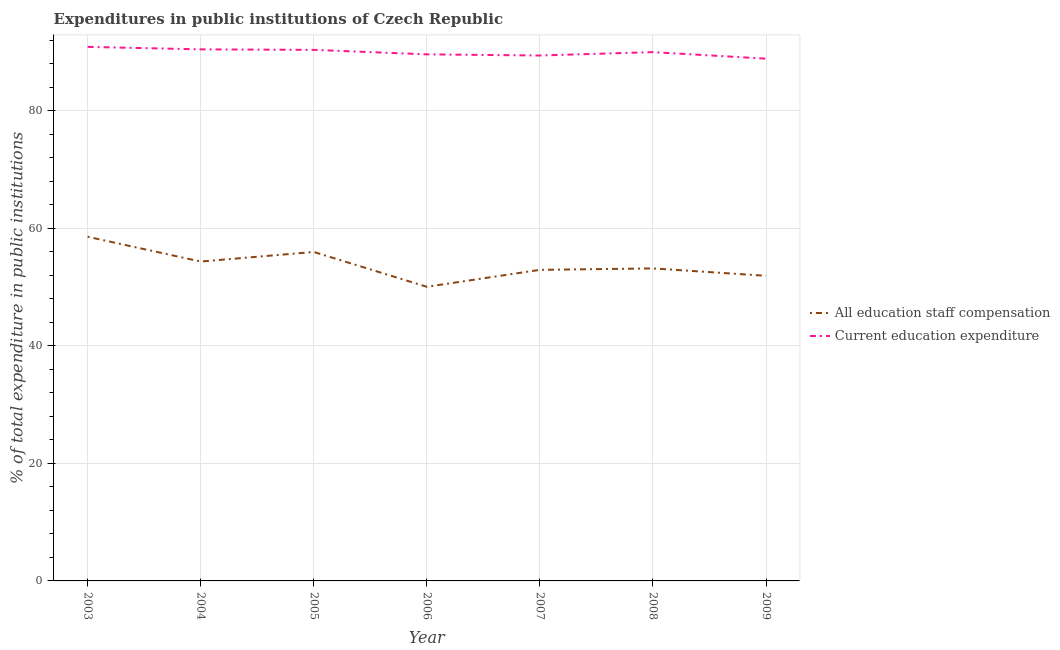How many different coloured lines are there?
Provide a short and direct response. 2. What is the expenditure in education in 2007?
Offer a very short reply. 89.38. Across all years, what is the maximum expenditure in staff compensation?
Give a very brief answer. 58.55. Across all years, what is the minimum expenditure in education?
Provide a short and direct response. 88.84. In which year was the expenditure in staff compensation maximum?
Keep it short and to the point. 2003. What is the total expenditure in staff compensation in the graph?
Make the answer very short. 376.86. What is the difference between the expenditure in education in 2006 and that in 2007?
Your response must be concise. 0.19. What is the difference between the expenditure in staff compensation in 2007 and the expenditure in education in 2008?
Offer a terse response. -37.04. What is the average expenditure in education per year?
Your response must be concise. 89.91. In the year 2003, what is the difference between the expenditure in education and expenditure in staff compensation?
Provide a short and direct response. 32.3. In how many years, is the expenditure in education greater than 60 %?
Provide a short and direct response. 7. What is the ratio of the expenditure in staff compensation in 2005 to that in 2008?
Your answer should be compact. 1.05. Is the difference between the expenditure in education in 2004 and 2009 greater than the difference between the expenditure in staff compensation in 2004 and 2009?
Ensure brevity in your answer.  No. What is the difference between the highest and the second highest expenditure in staff compensation?
Your response must be concise. 2.59. What is the difference between the highest and the lowest expenditure in staff compensation?
Keep it short and to the point. 8.51. How many years are there in the graph?
Keep it short and to the point. 7. What is the difference between two consecutive major ticks on the Y-axis?
Offer a very short reply. 20. Are the values on the major ticks of Y-axis written in scientific E-notation?
Provide a short and direct response. No. How many legend labels are there?
Provide a succinct answer. 2. How are the legend labels stacked?
Ensure brevity in your answer.  Vertical. What is the title of the graph?
Your answer should be very brief. Expenditures in public institutions of Czech Republic. What is the label or title of the X-axis?
Your response must be concise. Year. What is the label or title of the Y-axis?
Make the answer very short. % of total expenditure in public institutions. What is the % of total expenditure in public institutions of All education staff compensation in 2003?
Offer a very short reply. 58.55. What is the % of total expenditure in public institutions in Current education expenditure in 2003?
Provide a succinct answer. 90.85. What is the % of total expenditure in public institutions in All education staff compensation in 2004?
Give a very brief answer. 54.33. What is the % of total expenditure in public institutions in Current education expenditure in 2004?
Ensure brevity in your answer.  90.43. What is the % of total expenditure in public institutions of All education staff compensation in 2005?
Provide a short and direct response. 55.96. What is the % of total expenditure in public institutions in Current education expenditure in 2005?
Your response must be concise. 90.34. What is the % of total expenditure in public institutions of All education staff compensation in 2006?
Provide a succinct answer. 50.03. What is the % of total expenditure in public institutions in Current education expenditure in 2006?
Make the answer very short. 89.57. What is the % of total expenditure in public institutions in All education staff compensation in 2007?
Your response must be concise. 52.92. What is the % of total expenditure in public institutions in Current education expenditure in 2007?
Keep it short and to the point. 89.38. What is the % of total expenditure in public institutions of All education staff compensation in 2008?
Your answer should be compact. 53.16. What is the % of total expenditure in public institutions of Current education expenditure in 2008?
Offer a terse response. 89.96. What is the % of total expenditure in public institutions in All education staff compensation in 2009?
Your answer should be compact. 51.91. What is the % of total expenditure in public institutions in Current education expenditure in 2009?
Your answer should be very brief. 88.84. Across all years, what is the maximum % of total expenditure in public institutions in All education staff compensation?
Offer a terse response. 58.55. Across all years, what is the maximum % of total expenditure in public institutions of Current education expenditure?
Your response must be concise. 90.85. Across all years, what is the minimum % of total expenditure in public institutions in All education staff compensation?
Give a very brief answer. 50.03. Across all years, what is the minimum % of total expenditure in public institutions in Current education expenditure?
Provide a short and direct response. 88.84. What is the total % of total expenditure in public institutions of All education staff compensation in the graph?
Make the answer very short. 376.86. What is the total % of total expenditure in public institutions of Current education expenditure in the graph?
Offer a terse response. 629.37. What is the difference between the % of total expenditure in public institutions of All education staff compensation in 2003 and that in 2004?
Your answer should be compact. 4.22. What is the difference between the % of total expenditure in public institutions in Current education expenditure in 2003 and that in 2004?
Make the answer very short. 0.42. What is the difference between the % of total expenditure in public institutions in All education staff compensation in 2003 and that in 2005?
Offer a very short reply. 2.59. What is the difference between the % of total expenditure in public institutions of Current education expenditure in 2003 and that in 2005?
Keep it short and to the point. 0.51. What is the difference between the % of total expenditure in public institutions of All education staff compensation in 2003 and that in 2006?
Offer a terse response. 8.51. What is the difference between the % of total expenditure in public institutions in Current education expenditure in 2003 and that in 2006?
Ensure brevity in your answer.  1.27. What is the difference between the % of total expenditure in public institutions of All education staff compensation in 2003 and that in 2007?
Your answer should be very brief. 5.63. What is the difference between the % of total expenditure in public institutions of Current education expenditure in 2003 and that in 2007?
Your answer should be very brief. 1.47. What is the difference between the % of total expenditure in public institutions of All education staff compensation in 2003 and that in 2008?
Ensure brevity in your answer.  5.39. What is the difference between the % of total expenditure in public institutions of Current education expenditure in 2003 and that in 2008?
Your answer should be compact. 0.89. What is the difference between the % of total expenditure in public institutions in All education staff compensation in 2003 and that in 2009?
Your response must be concise. 6.64. What is the difference between the % of total expenditure in public institutions in Current education expenditure in 2003 and that in 2009?
Offer a terse response. 2.01. What is the difference between the % of total expenditure in public institutions of All education staff compensation in 2004 and that in 2005?
Your response must be concise. -1.63. What is the difference between the % of total expenditure in public institutions in Current education expenditure in 2004 and that in 2005?
Make the answer very short. 0.09. What is the difference between the % of total expenditure in public institutions in All education staff compensation in 2004 and that in 2006?
Your answer should be compact. 4.3. What is the difference between the % of total expenditure in public institutions in Current education expenditure in 2004 and that in 2006?
Give a very brief answer. 0.85. What is the difference between the % of total expenditure in public institutions in All education staff compensation in 2004 and that in 2007?
Your answer should be very brief. 1.41. What is the difference between the % of total expenditure in public institutions of Current education expenditure in 2004 and that in 2007?
Ensure brevity in your answer.  1.04. What is the difference between the % of total expenditure in public institutions of All education staff compensation in 2004 and that in 2008?
Make the answer very short. 1.17. What is the difference between the % of total expenditure in public institutions of Current education expenditure in 2004 and that in 2008?
Provide a short and direct response. 0.47. What is the difference between the % of total expenditure in public institutions of All education staff compensation in 2004 and that in 2009?
Your response must be concise. 2.42. What is the difference between the % of total expenditure in public institutions in Current education expenditure in 2004 and that in 2009?
Ensure brevity in your answer.  1.58. What is the difference between the % of total expenditure in public institutions of All education staff compensation in 2005 and that in 2006?
Give a very brief answer. 5.93. What is the difference between the % of total expenditure in public institutions of Current education expenditure in 2005 and that in 2006?
Give a very brief answer. 0.77. What is the difference between the % of total expenditure in public institutions of All education staff compensation in 2005 and that in 2007?
Make the answer very short. 3.04. What is the difference between the % of total expenditure in public institutions in Current education expenditure in 2005 and that in 2007?
Ensure brevity in your answer.  0.96. What is the difference between the % of total expenditure in public institutions of All education staff compensation in 2005 and that in 2008?
Ensure brevity in your answer.  2.8. What is the difference between the % of total expenditure in public institutions of Current education expenditure in 2005 and that in 2008?
Ensure brevity in your answer.  0.38. What is the difference between the % of total expenditure in public institutions in All education staff compensation in 2005 and that in 2009?
Your answer should be very brief. 4.06. What is the difference between the % of total expenditure in public institutions of Current education expenditure in 2005 and that in 2009?
Provide a short and direct response. 1.5. What is the difference between the % of total expenditure in public institutions in All education staff compensation in 2006 and that in 2007?
Your response must be concise. -2.88. What is the difference between the % of total expenditure in public institutions in Current education expenditure in 2006 and that in 2007?
Make the answer very short. 0.19. What is the difference between the % of total expenditure in public institutions of All education staff compensation in 2006 and that in 2008?
Your response must be concise. -3.13. What is the difference between the % of total expenditure in public institutions in Current education expenditure in 2006 and that in 2008?
Ensure brevity in your answer.  -0.38. What is the difference between the % of total expenditure in public institutions in All education staff compensation in 2006 and that in 2009?
Your answer should be compact. -1.87. What is the difference between the % of total expenditure in public institutions in Current education expenditure in 2006 and that in 2009?
Keep it short and to the point. 0.73. What is the difference between the % of total expenditure in public institutions in All education staff compensation in 2007 and that in 2008?
Your answer should be very brief. -0.24. What is the difference between the % of total expenditure in public institutions of Current education expenditure in 2007 and that in 2008?
Give a very brief answer. -0.57. What is the difference between the % of total expenditure in public institutions in All education staff compensation in 2007 and that in 2009?
Provide a succinct answer. 1.01. What is the difference between the % of total expenditure in public institutions of Current education expenditure in 2007 and that in 2009?
Provide a succinct answer. 0.54. What is the difference between the % of total expenditure in public institutions in All education staff compensation in 2008 and that in 2009?
Keep it short and to the point. 1.25. What is the difference between the % of total expenditure in public institutions of Current education expenditure in 2008 and that in 2009?
Your answer should be compact. 1.11. What is the difference between the % of total expenditure in public institutions of All education staff compensation in 2003 and the % of total expenditure in public institutions of Current education expenditure in 2004?
Your answer should be compact. -31.88. What is the difference between the % of total expenditure in public institutions in All education staff compensation in 2003 and the % of total expenditure in public institutions in Current education expenditure in 2005?
Your response must be concise. -31.79. What is the difference between the % of total expenditure in public institutions of All education staff compensation in 2003 and the % of total expenditure in public institutions of Current education expenditure in 2006?
Keep it short and to the point. -31.03. What is the difference between the % of total expenditure in public institutions in All education staff compensation in 2003 and the % of total expenditure in public institutions in Current education expenditure in 2007?
Your answer should be very brief. -30.83. What is the difference between the % of total expenditure in public institutions in All education staff compensation in 2003 and the % of total expenditure in public institutions in Current education expenditure in 2008?
Give a very brief answer. -31.41. What is the difference between the % of total expenditure in public institutions in All education staff compensation in 2003 and the % of total expenditure in public institutions in Current education expenditure in 2009?
Your answer should be very brief. -30.29. What is the difference between the % of total expenditure in public institutions of All education staff compensation in 2004 and the % of total expenditure in public institutions of Current education expenditure in 2005?
Make the answer very short. -36.01. What is the difference between the % of total expenditure in public institutions of All education staff compensation in 2004 and the % of total expenditure in public institutions of Current education expenditure in 2006?
Offer a very short reply. -35.24. What is the difference between the % of total expenditure in public institutions of All education staff compensation in 2004 and the % of total expenditure in public institutions of Current education expenditure in 2007?
Offer a terse response. -35.05. What is the difference between the % of total expenditure in public institutions of All education staff compensation in 2004 and the % of total expenditure in public institutions of Current education expenditure in 2008?
Offer a terse response. -35.62. What is the difference between the % of total expenditure in public institutions in All education staff compensation in 2004 and the % of total expenditure in public institutions in Current education expenditure in 2009?
Provide a short and direct response. -34.51. What is the difference between the % of total expenditure in public institutions in All education staff compensation in 2005 and the % of total expenditure in public institutions in Current education expenditure in 2006?
Provide a succinct answer. -33.61. What is the difference between the % of total expenditure in public institutions in All education staff compensation in 2005 and the % of total expenditure in public institutions in Current education expenditure in 2007?
Provide a short and direct response. -33.42. What is the difference between the % of total expenditure in public institutions of All education staff compensation in 2005 and the % of total expenditure in public institutions of Current education expenditure in 2008?
Offer a terse response. -33.99. What is the difference between the % of total expenditure in public institutions in All education staff compensation in 2005 and the % of total expenditure in public institutions in Current education expenditure in 2009?
Ensure brevity in your answer.  -32.88. What is the difference between the % of total expenditure in public institutions in All education staff compensation in 2006 and the % of total expenditure in public institutions in Current education expenditure in 2007?
Offer a very short reply. -39.35. What is the difference between the % of total expenditure in public institutions of All education staff compensation in 2006 and the % of total expenditure in public institutions of Current education expenditure in 2008?
Provide a succinct answer. -39.92. What is the difference between the % of total expenditure in public institutions of All education staff compensation in 2006 and the % of total expenditure in public institutions of Current education expenditure in 2009?
Make the answer very short. -38.81. What is the difference between the % of total expenditure in public institutions in All education staff compensation in 2007 and the % of total expenditure in public institutions in Current education expenditure in 2008?
Your answer should be compact. -37.04. What is the difference between the % of total expenditure in public institutions of All education staff compensation in 2007 and the % of total expenditure in public institutions of Current education expenditure in 2009?
Give a very brief answer. -35.92. What is the difference between the % of total expenditure in public institutions in All education staff compensation in 2008 and the % of total expenditure in public institutions in Current education expenditure in 2009?
Your response must be concise. -35.68. What is the average % of total expenditure in public institutions in All education staff compensation per year?
Your answer should be compact. 53.84. What is the average % of total expenditure in public institutions in Current education expenditure per year?
Offer a terse response. 89.91. In the year 2003, what is the difference between the % of total expenditure in public institutions in All education staff compensation and % of total expenditure in public institutions in Current education expenditure?
Your response must be concise. -32.3. In the year 2004, what is the difference between the % of total expenditure in public institutions in All education staff compensation and % of total expenditure in public institutions in Current education expenditure?
Offer a very short reply. -36.1. In the year 2005, what is the difference between the % of total expenditure in public institutions of All education staff compensation and % of total expenditure in public institutions of Current education expenditure?
Give a very brief answer. -34.38. In the year 2006, what is the difference between the % of total expenditure in public institutions in All education staff compensation and % of total expenditure in public institutions in Current education expenditure?
Offer a terse response. -39.54. In the year 2007, what is the difference between the % of total expenditure in public institutions in All education staff compensation and % of total expenditure in public institutions in Current education expenditure?
Ensure brevity in your answer.  -36.46. In the year 2008, what is the difference between the % of total expenditure in public institutions of All education staff compensation and % of total expenditure in public institutions of Current education expenditure?
Make the answer very short. -36.79. In the year 2009, what is the difference between the % of total expenditure in public institutions of All education staff compensation and % of total expenditure in public institutions of Current education expenditure?
Your response must be concise. -36.94. What is the ratio of the % of total expenditure in public institutions in All education staff compensation in 2003 to that in 2004?
Your answer should be very brief. 1.08. What is the ratio of the % of total expenditure in public institutions of All education staff compensation in 2003 to that in 2005?
Provide a succinct answer. 1.05. What is the ratio of the % of total expenditure in public institutions in Current education expenditure in 2003 to that in 2005?
Your response must be concise. 1.01. What is the ratio of the % of total expenditure in public institutions of All education staff compensation in 2003 to that in 2006?
Keep it short and to the point. 1.17. What is the ratio of the % of total expenditure in public institutions of Current education expenditure in 2003 to that in 2006?
Your response must be concise. 1.01. What is the ratio of the % of total expenditure in public institutions of All education staff compensation in 2003 to that in 2007?
Ensure brevity in your answer.  1.11. What is the ratio of the % of total expenditure in public institutions of Current education expenditure in 2003 to that in 2007?
Ensure brevity in your answer.  1.02. What is the ratio of the % of total expenditure in public institutions of All education staff compensation in 2003 to that in 2008?
Your response must be concise. 1.1. What is the ratio of the % of total expenditure in public institutions of Current education expenditure in 2003 to that in 2008?
Provide a short and direct response. 1.01. What is the ratio of the % of total expenditure in public institutions of All education staff compensation in 2003 to that in 2009?
Provide a short and direct response. 1.13. What is the ratio of the % of total expenditure in public institutions in Current education expenditure in 2003 to that in 2009?
Keep it short and to the point. 1.02. What is the ratio of the % of total expenditure in public institutions in All education staff compensation in 2004 to that in 2005?
Your response must be concise. 0.97. What is the ratio of the % of total expenditure in public institutions in All education staff compensation in 2004 to that in 2006?
Make the answer very short. 1.09. What is the ratio of the % of total expenditure in public institutions in Current education expenditure in 2004 to that in 2006?
Keep it short and to the point. 1.01. What is the ratio of the % of total expenditure in public institutions in All education staff compensation in 2004 to that in 2007?
Your answer should be compact. 1.03. What is the ratio of the % of total expenditure in public institutions of Current education expenditure in 2004 to that in 2007?
Keep it short and to the point. 1.01. What is the ratio of the % of total expenditure in public institutions of All education staff compensation in 2004 to that in 2009?
Your answer should be compact. 1.05. What is the ratio of the % of total expenditure in public institutions of Current education expenditure in 2004 to that in 2009?
Your answer should be very brief. 1.02. What is the ratio of the % of total expenditure in public institutions in All education staff compensation in 2005 to that in 2006?
Your answer should be very brief. 1.12. What is the ratio of the % of total expenditure in public institutions in Current education expenditure in 2005 to that in 2006?
Give a very brief answer. 1.01. What is the ratio of the % of total expenditure in public institutions of All education staff compensation in 2005 to that in 2007?
Your response must be concise. 1.06. What is the ratio of the % of total expenditure in public institutions of Current education expenditure in 2005 to that in 2007?
Provide a succinct answer. 1.01. What is the ratio of the % of total expenditure in public institutions in All education staff compensation in 2005 to that in 2008?
Make the answer very short. 1.05. What is the ratio of the % of total expenditure in public institutions of All education staff compensation in 2005 to that in 2009?
Your response must be concise. 1.08. What is the ratio of the % of total expenditure in public institutions of Current education expenditure in 2005 to that in 2009?
Keep it short and to the point. 1.02. What is the ratio of the % of total expenditure in public institutions in All education staff compensation in 2006 to that in 2007?
Keep it short and to the point. 0.95. What is the ratio of the % of total expenditure in public institutions in Current education expenditure in 2006 to that in 2007?
Offer a terse response. 1. What is the ratio of the % of total expenditure in public institutions of All education staff compensation in 2006 to that in 2009?
Your answer should be compact. 0.96. What is the ratio of the % of total expenditure in public institutions of Current education expenditure in 2006 to that in 2009?
Offer a terse response. 1.01. What is the ratio of the % of total expenditure in public institutions in All education staff compensation in 2007 to that in 2009?
Provide a succinct answer. 1.02. What is the ratio of the % of total expenditure in public institutions of All education staff compensation in 2008 to that in 2009?
Provide a succinct answer. 1.02. What is the ratio of the % of total expenditure in public institutions in Current education expenditure in 2008 to that in 2009?
Offer a very short reply. 1.01. What is the difference between the highest and the second highest % of total expenditure in public institutions in All education staff compensation?
Your answer should be compact. 2.59. What is the difference between the highest and the second highest % of total expenditure in public institutions in Current education expenditure?
Make the answer very short. 0.42. What is the difference between the highest and the lowest % of total expenditure in public institutions of All education staff compensation?
Make the answer very short. 8.51. What is the difference between the highest and the lowest % of total expenditure in public institutions in Current education expenditure?
Make the answer very short. 2.01. 